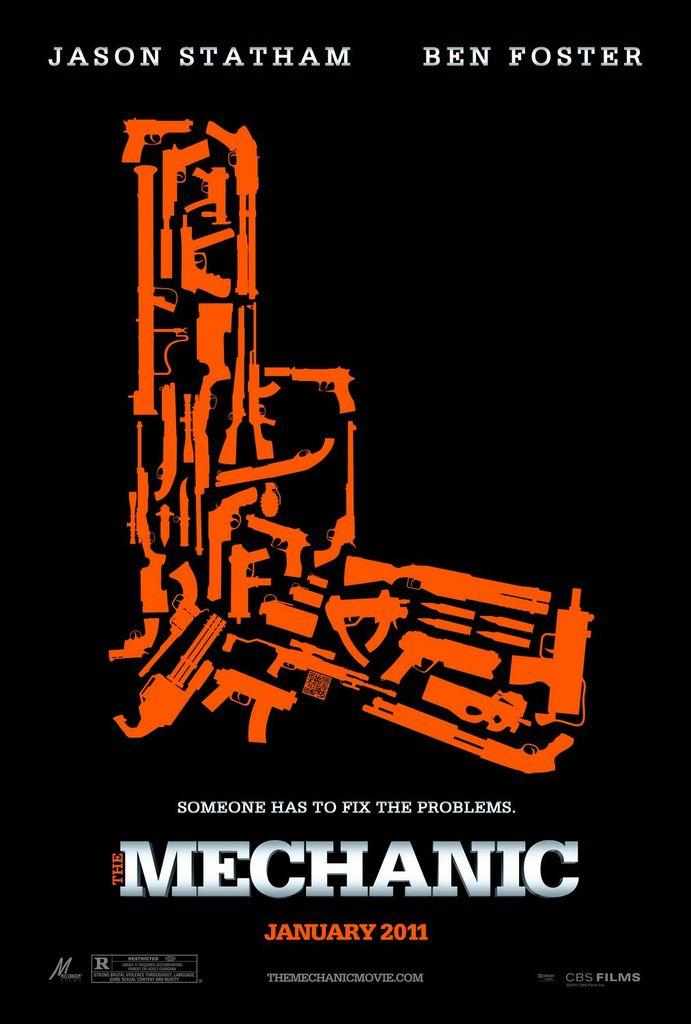<image>
Create a compact narrative representing the image presented. An ad for a Jason Statham movie says it comes out in January. 